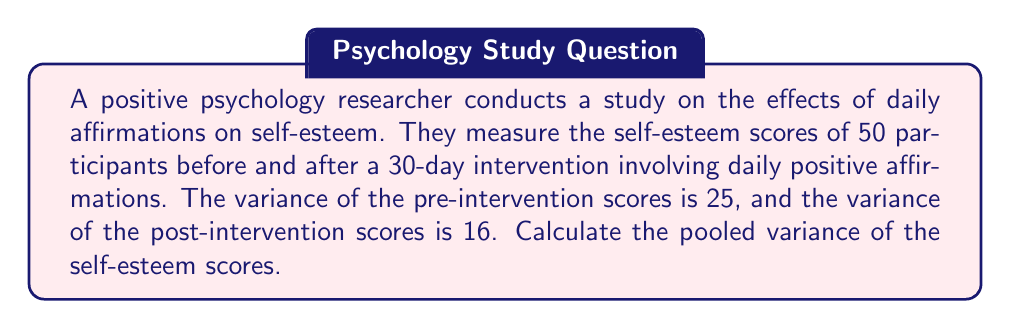Provide a solution to this math problem. To solve this problem, we need to understand the concept of pooled variance and follow these steps:

1) Pooled variance is used when we want to combine the variances of two or more groups with equal sample sizes. The formula for pooled variance is:

   $$ s_p^2 = \frac{(n_1 - 1)s_1^2 + (n_2 - 1)s_2^2}{n_1 + n_2 - 2} $$

   Where:
   $s_p^2$ is the pooled variance
   $n_1$ and $n_2$ are the sample sizes of the two groups
   $s_1^2$ and $s_2^2$ are the variances of the two groups

2) In this case:
   $n_1 = n_2 = 50$ (50 participants in each group)
   $s_1^2 = 25$ (pre-intervention variance)
   $s_2^2 = 16$ (post-intervention variance)

3) Let's substitute these values into the formula:

   $$ s_p^2 = \frac{(50 - 1)25 + (50 - 1)16}{50 + 50 - 2} $$

4) Simplify:
   $$ s_p^2 = \frac{49(25) + 49(16)}{98} $$

5) Calculate:
   $$ s_p^2 = \frac{1225 + 784}{98} = \frac{2009}{98} $$

6) Divide:
   $$ s_p^2 = 20.5 $$

Therefore, the pooled variance of the self-esteem scores is 20.5.
Answer: 20.5 